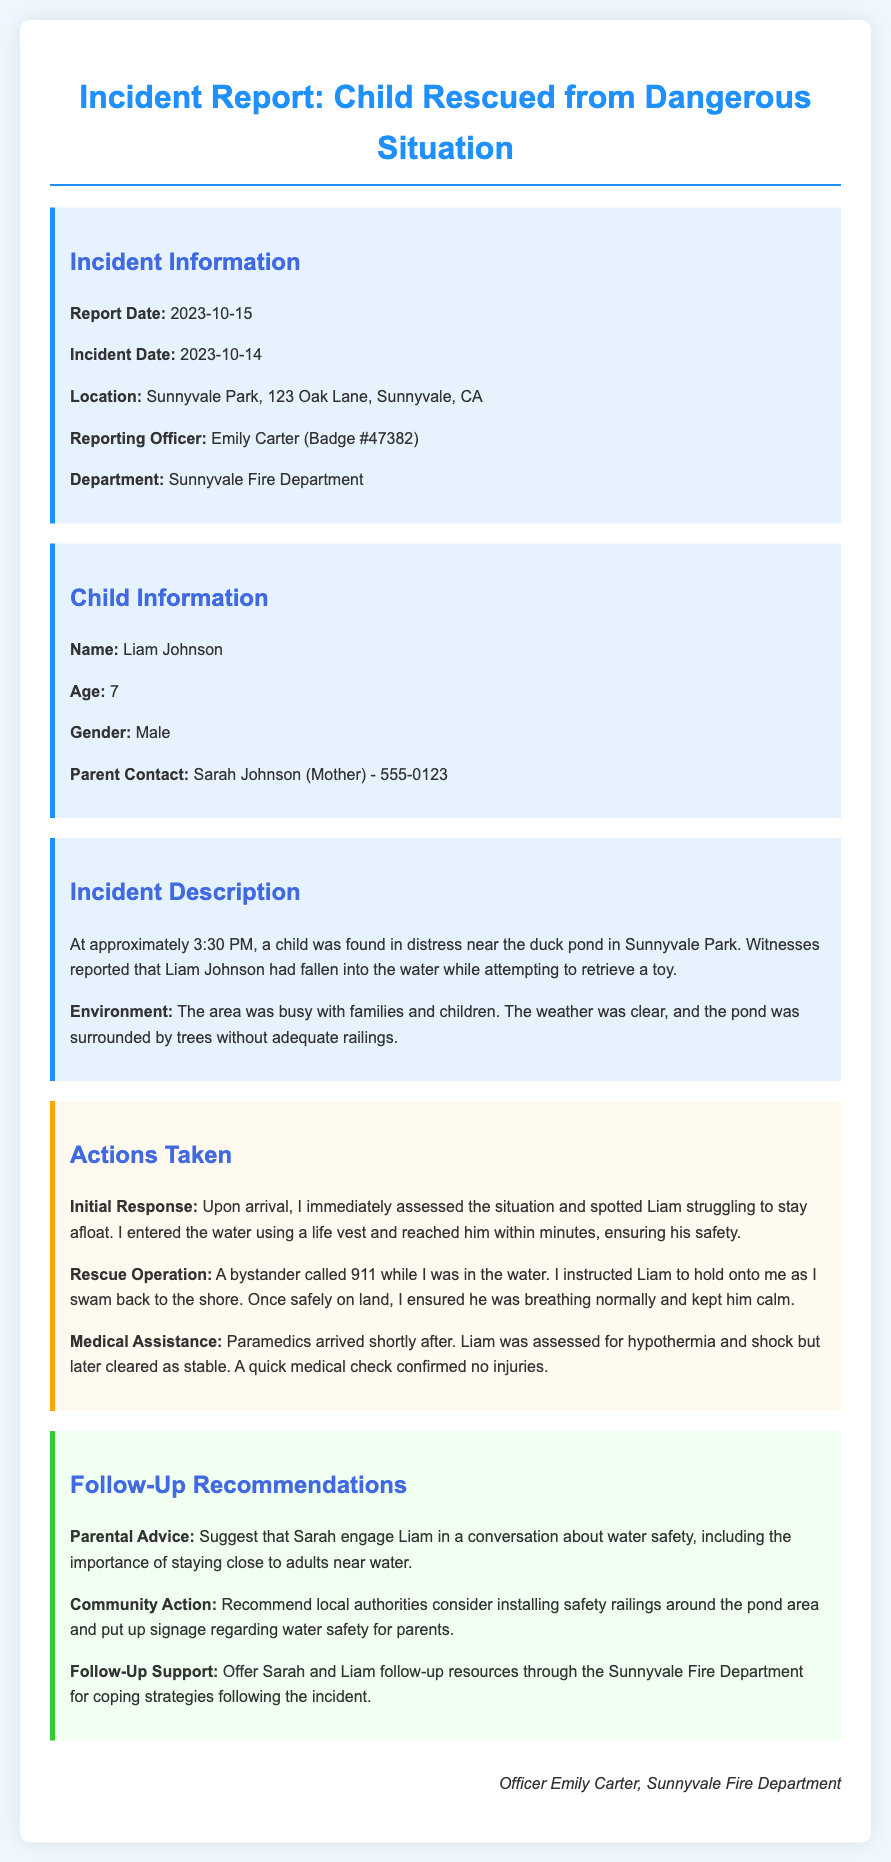What is the report date? The report date is mentioned in the Incident Information section of the document.
Answer: 2023-10-15 What is the name of the child rescued? The child's name is provided in the Child Information section.
Answer: Liam Johnson What time did the incident occur? The incident time is stated in the Incident Description section.
Answer: 3:30 PM What safety recommendation is suggested for parents? The recommendation for parents is detailed in the Follow-Up Recommendations section.
Answer: Water safety conversation Who was the reporting officer? The reporting officer's name is specified in the Incident Information section.
Answer: Emily Carter What was Liam doing near the pond? This information is detailed in the Incident Description section regarding Liam's actions at the pond.
Answer: Retrieving a toy What medical condition was Liam assessed for? The medical assessment condition is mentioned in the Actions Taken section.
Answer: Hypothermia What department does the reporting officer belong to? The department of the reporting officer is found in the Incident Information section.
Answer: Sunnyvale Fire Department What action did the bystander take during the rescue? This action taken by the bystander is described in the Actions Taken section.
Answer: Called 911 